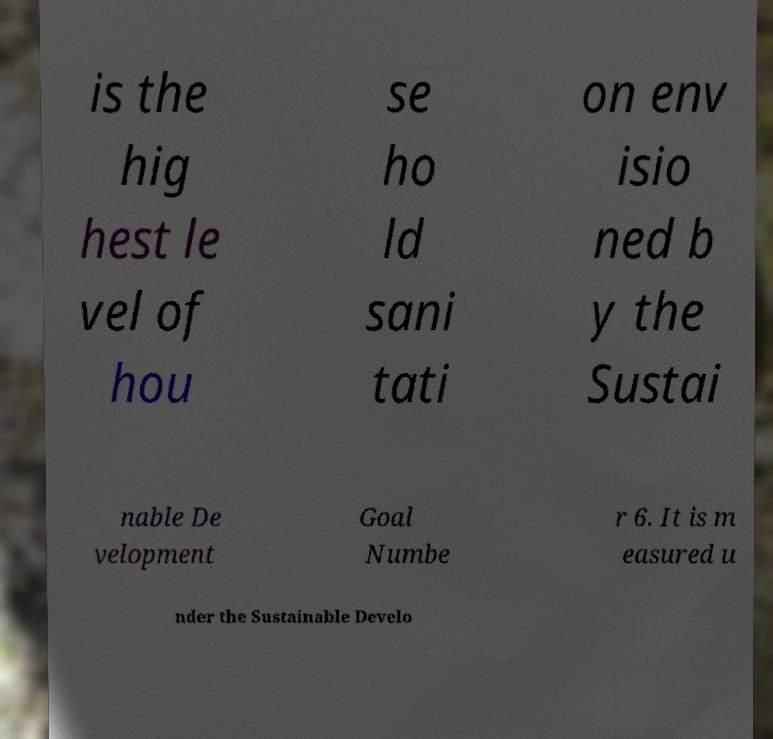There's text embedded in this image that I need extracted. Can you transcribe it verbatim? is the hig hest le vel of hou se ho ld sani tati on env isio ned b y the Sustai nable De velopment Goal Numbe r 6. It is m easured u nder the Sustainable Develo 